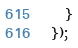<code> <loc_0><loc_0><loc_500><loc_500><_JavaScript_>  }
});
</code> 